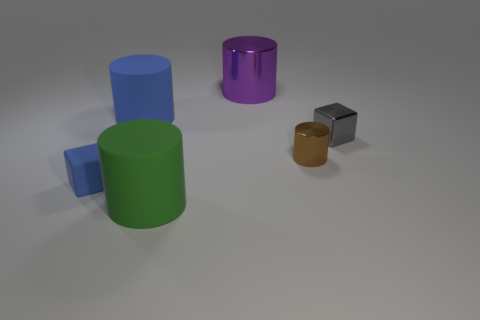Add 4 blocks. How many objects exist? 10 Subtract all cylinders. How many objects are left? 2 Subtract all small brown metal objects. Subtract all tiny metallic blocks. How many objects are left? 4 Add 1 big green rubber things. How many big green rubber things are left? 2 Add 6 gray metallic spheres. How many gray metallic spheres exist? 6 Subtract 0 red balls. How many objects are left? 6 